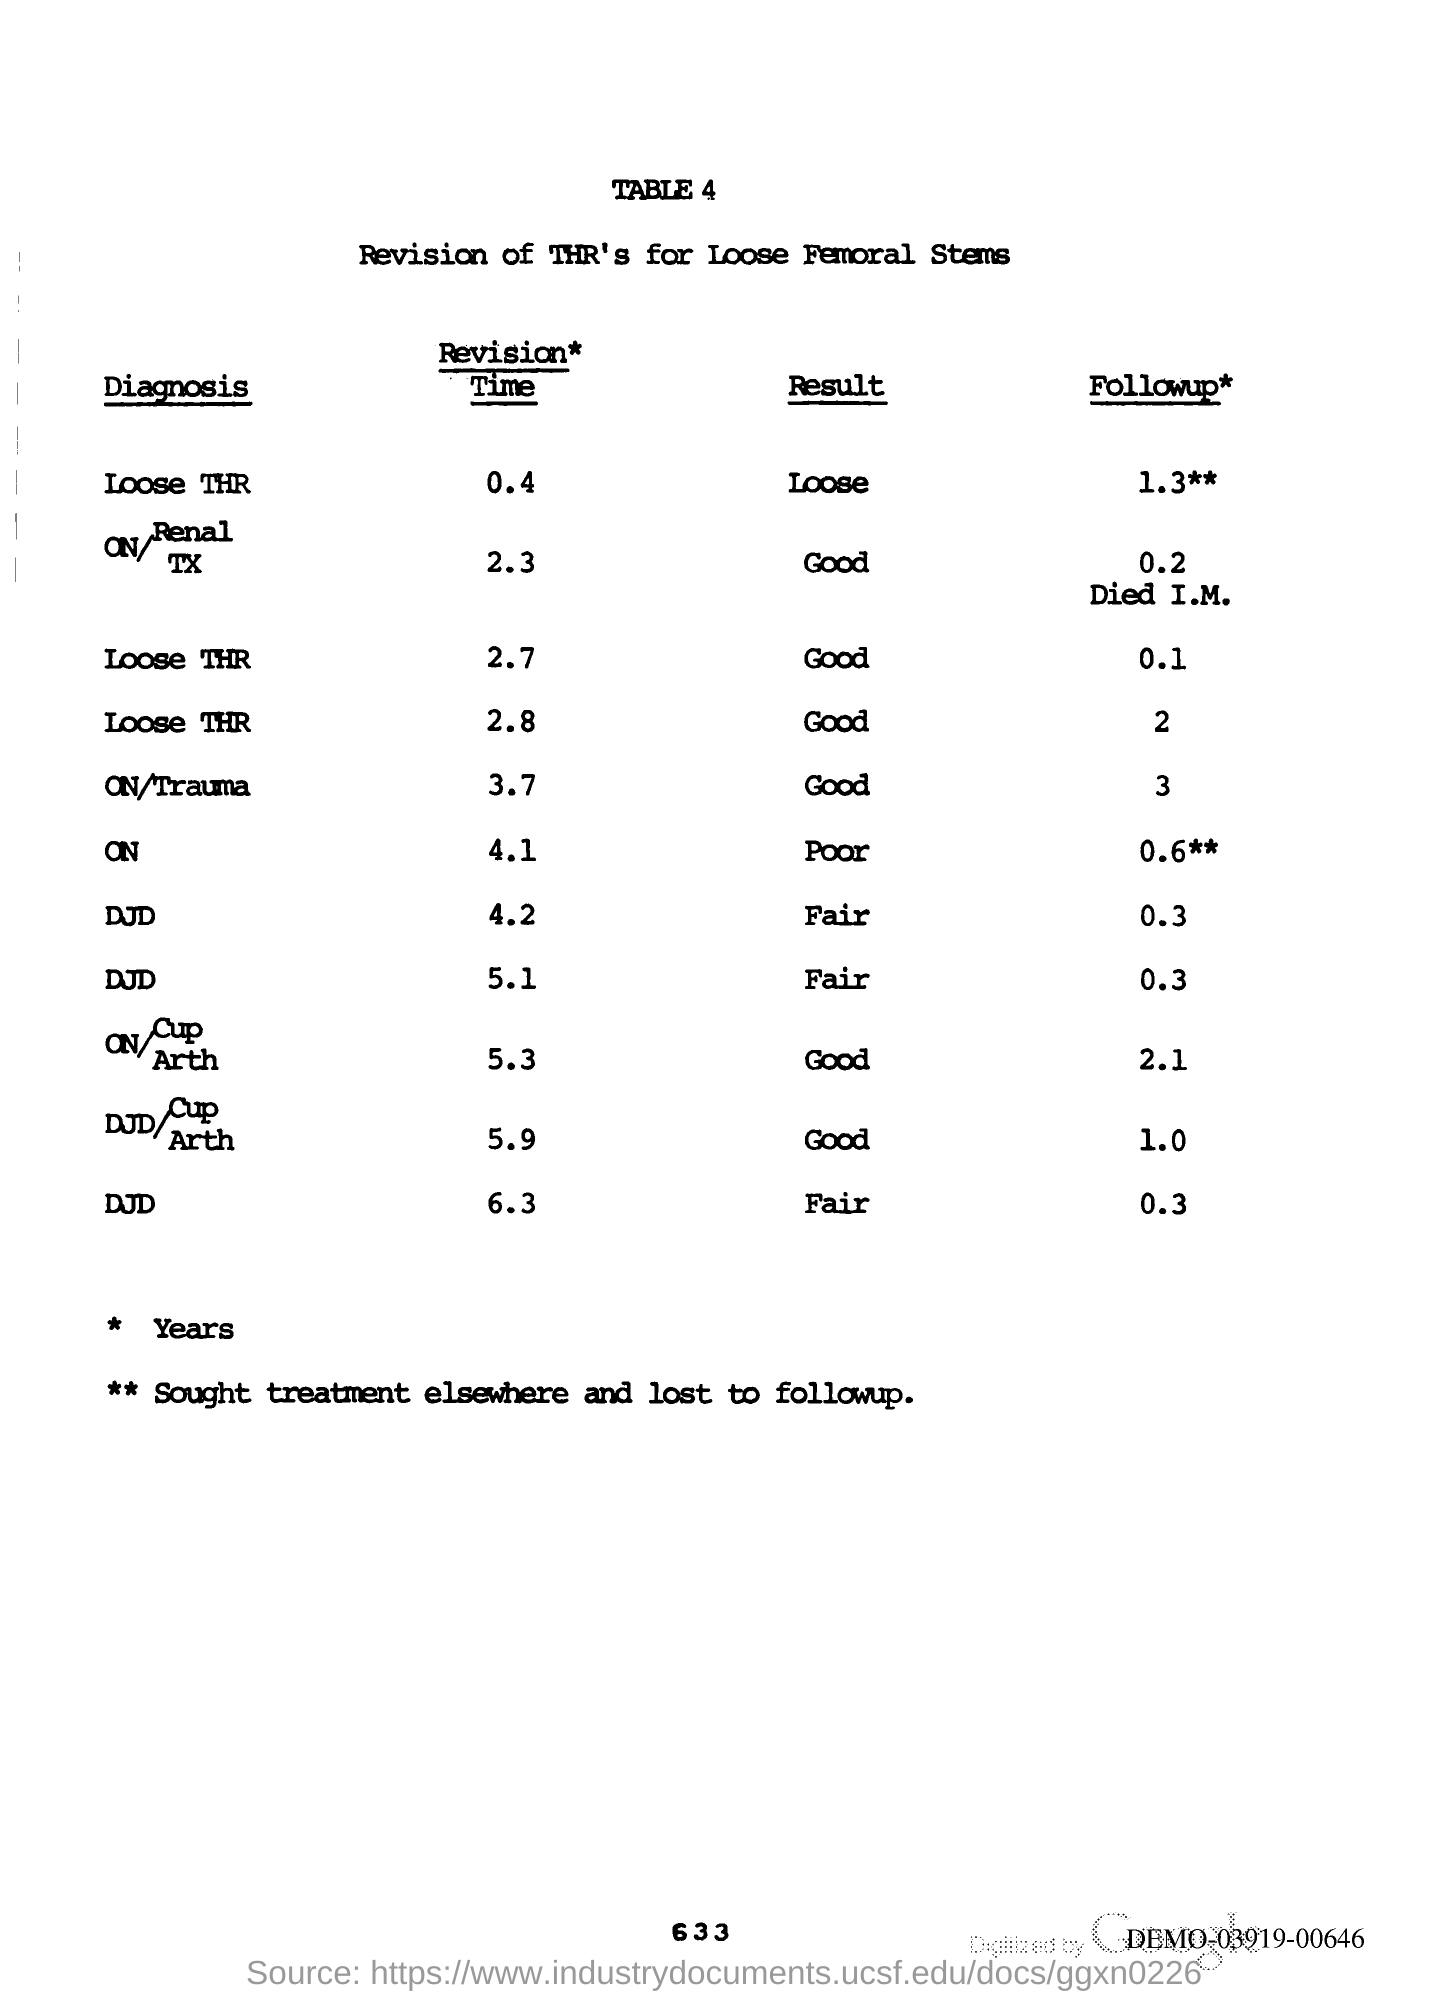What is the Page Number?
Make the answer very short. 633. 